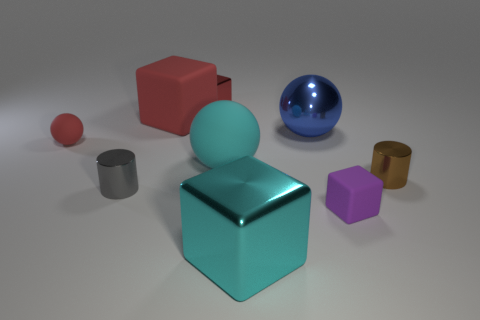If this were a scene from a story, what mood might it convey? If this image were part of a narrative, the mood could be described as contemplative or introspective, inviting the viewer to reflect on the simplicity and diversity of the objects. The soft lighting and pastel colors contribute to a serene and harmonious atmosphere. 